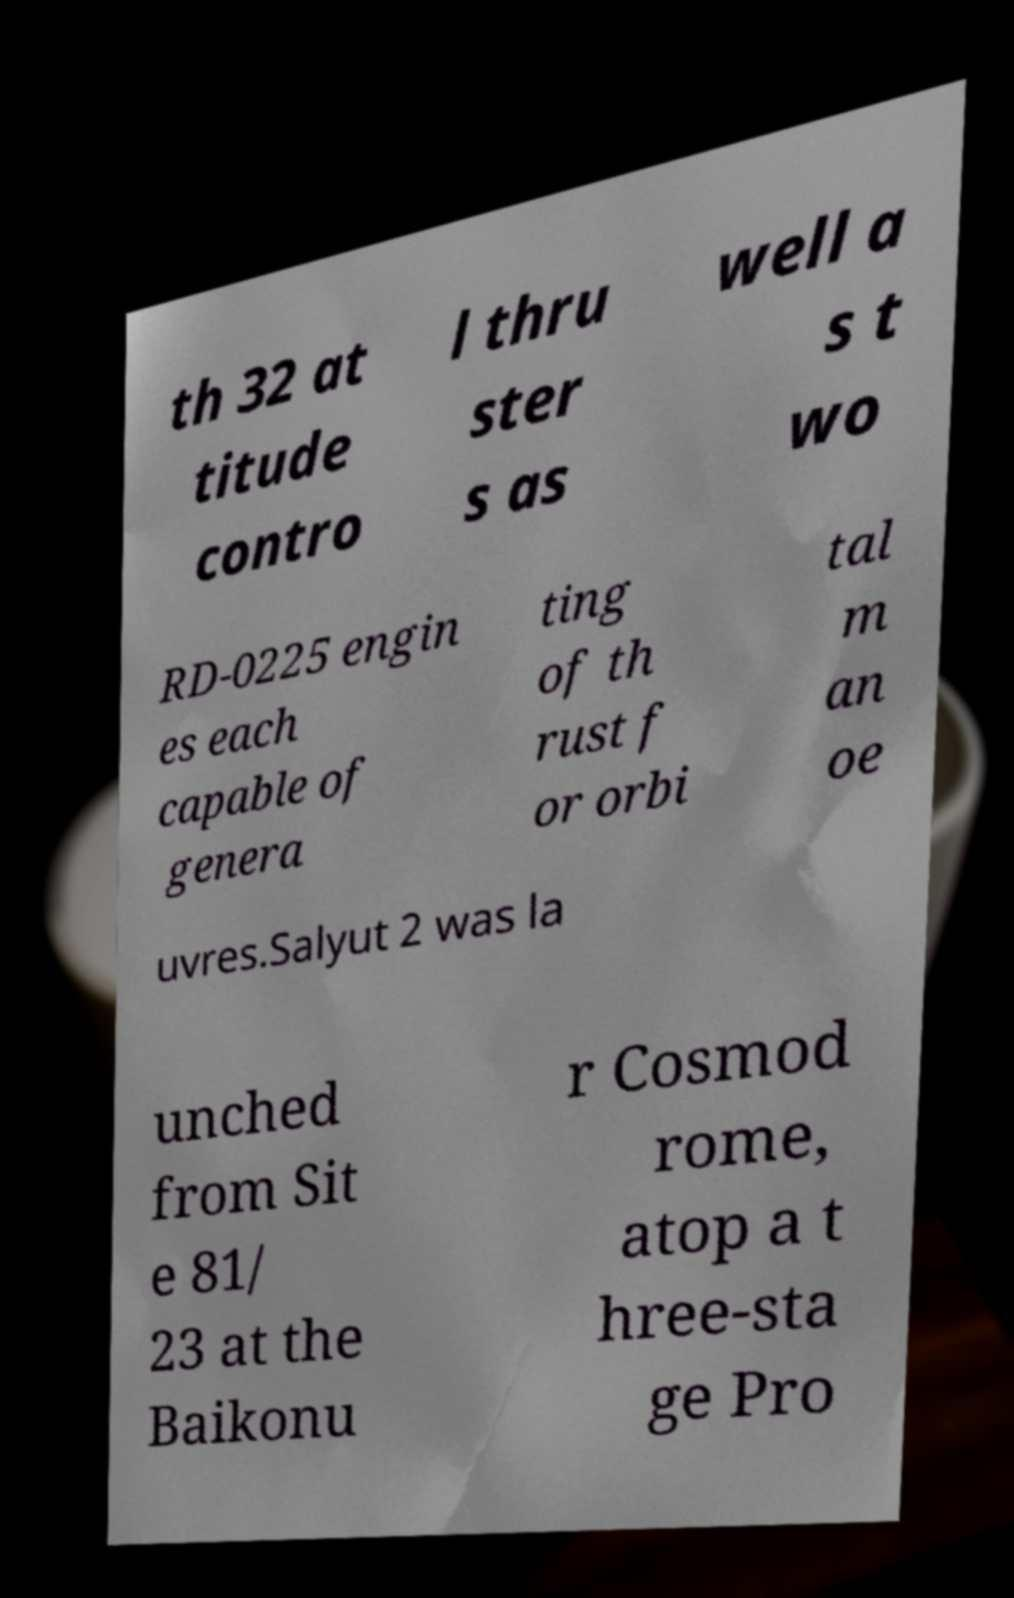For documentation purposes, I need the text within this image transcribed. Could you provide that? th 32 at titude contro l thru ster s as well a s t wo RD-0225 engin es each capable of genera ting of th rust f or orbi tal m an oe uvres.Salyut 2 was la unched from Sit e 81/ 23 at the Baikonu r Cosmod rome, atop a t hree-sta ge Pro 